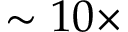<formula> <loc_0><loc_0><loc_500><loc_500>\sim 1 0 \times</formula> 